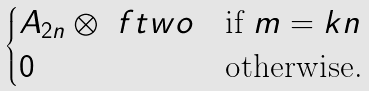Convert formula to latex. <formula><loc_0><loc_0><loc_500><loc_500>\begin{cases} A _ { 2 n } \otimes \ f t w o & \text {if } m = k n \\ 0 & \text {otherwise.} \end{cases}</formula> 